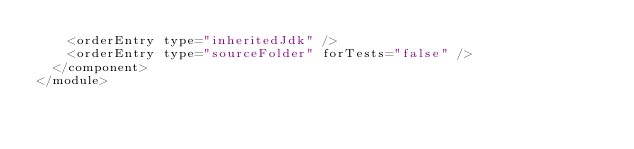<code> <loc_0><loc_0><loc_500><loc_500><_XML_>    <orderEntry type="inheritedJdk" />
    <orderEntry type="sourceFolder" forTests="false" />
  </component>
</module></code> 